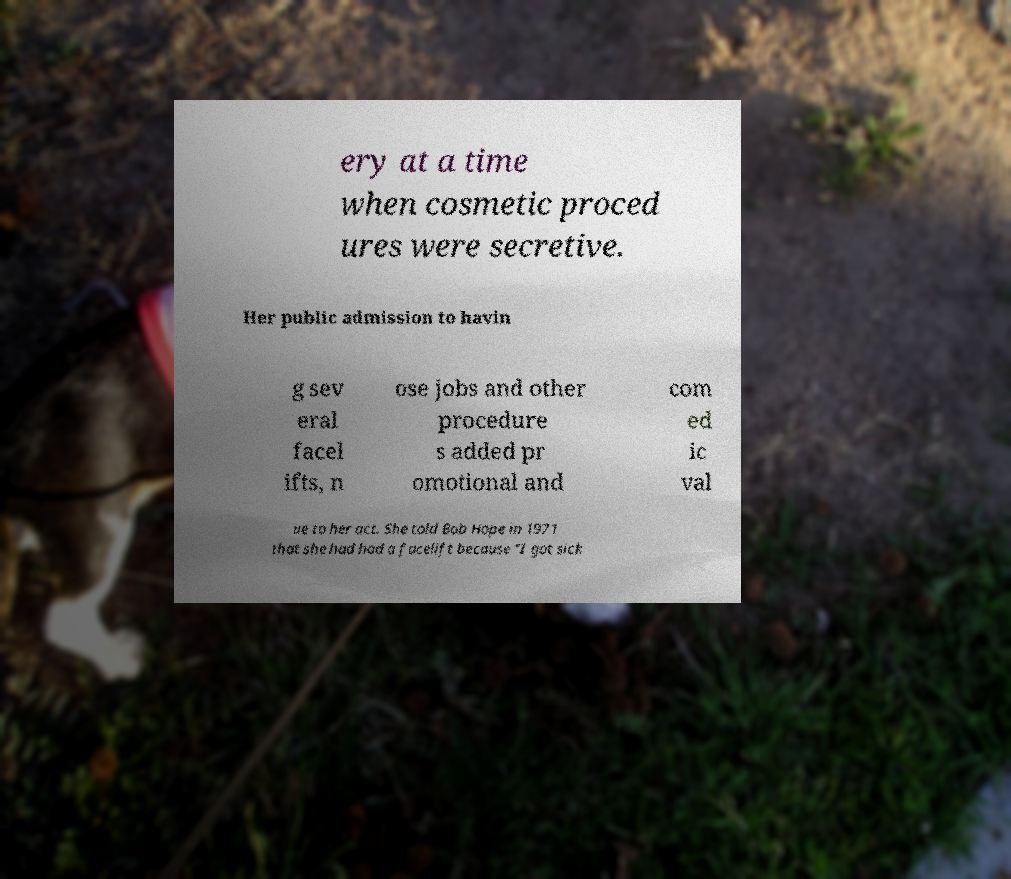There's text embedded in this image that I need extracted. Can you transcribe it verbatim? ery at a time when cosmetic proced ures were secretive. Her public admission to havin g sev eral facel ifts, n ose jobs and other procedure s added pr omotional and com ed ic val ue to her act. She told Bob Hope in 1971 that she had had a facelift because "I got sick 